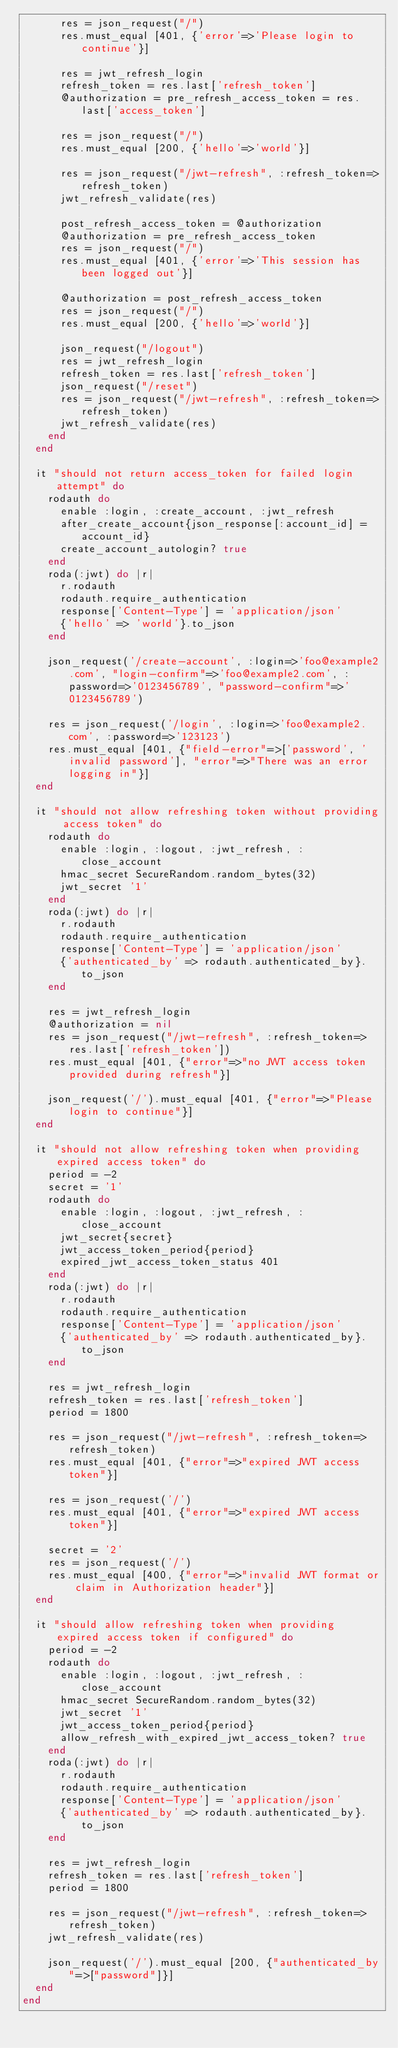Convert code to text. <code><loc_0><loc_0><loc_500><loc_500><_Ruby_>      res = json_request("/")
      res.must_equal [401, {'error'=>'Please login to continue'}]

      res = jwt_refresh_login
      refresh_token = res.last['refresh_token']
      @authorization = pre_refresh_access_token = res.last['access_token']

      res = json_request("/")
      res.must_equal [200, {'hello'=>'world'}]

      res = json_request("/jwt-refresh", :refresh_token=>refresh_token)
      jwt_refresh_validate(res)

      post_refresh_access_token = @authorization
      @authorization = pre_refresh_access_token
      res = json_request("/")
      res.must_equal [401, {'error'=>'This session has been logged out'}]

      @authorization = post_refresh_access_token
      res = json_request("/")
      res.must_equal [200, {'hello'=>'world'}]

      json_request("/logout")
      res = jwt_refresh_login
      refresh_token = res.last['refresh_token']
      json_request("/reset")
      res = json_request("/jwt-refresh", :refresh_token=>refresh_token)
      jwt_refresh_validate(res)
    end
  end

  it "should not return access_token for failed login attempt" do
    rodauth do
      enable :login, :create_account, :jwt_refresh
      after_create_account{json_response[:account_id] = account_id}
      create_account_autologin? true
    end
    roda(:jwt) do |r|
      r.rodauth
      rodauth.require_authentication
      response['Content-Type'] = 'application/json'
      {'hello' => 'world'}.to_json
    end

    json_request('/create-account', :login=>'foo@example2.com', "login-confirm"=>'foo@example2.com', :password=>'0123456789', "password-confirm"=>'0123456789')

    res = json_request('/login', :login=>'foo@example2.com', :password=>'123123')
    res.must_equal [401, {"field-error"=>['password', 'invalid password'], "error"=>"There was an error logging in"}]
  end

  it "should not allow refreshing token without providing access token" do
    rodauth do
      enable :login, :logout, :jwt_refresh, :close_account
      hmac_secret SecureRandom.random_bytes(32)
      jwt_secret '1'
    end
    roda(:jwt) do |r|
      r.rodauth
      rodauth.require_authentication
      response['Content-Type'] = 'application/json'
      {'authenticated_by' => rodauth.authenticated_by}.to_json
    end

    res = jwt_refresh_login
    @authorization = nil
    res = json_request("/jwt-refresh", :refresh_token=>res.last['refresh_token'])
    res.must_equal [401, {"error"=>"no JWT access token provided during refresh"}]

    json_request('/').must_equal [401, {"error"=>"Please login to continue"}]
  end

  it "should not allow refreshing token when providing expired access token" do
    period = -2
    secret = '1'
    rodauth do
      enable :login, :logout, :jwt_refresh, :close_account
      jwt_secret{secret}
      jwt_access_token_period{period}
      expired_jwt_access_token_status 401
    end
    roda(:jwt) do |r|
      r.rodauth
      rodauth.require_authentication
      response['Content-Type'] = 'application/json'
      {'authenticated_by' => rodauth.authenticated_by}.to_json
    end

    res = jwt_refresh_login
    refresh_token = res.last['refresh_token']
    period = 1800

    res = json_request("/jwt-refresh", :refresh_token=>refresh_token)
    res.must_equal [401, {"error"=>"expired JWT access token"}]

    res = json_request('/')
    res.must_equal [401, {"error"=>"expired JWT access token"}]

    secret = '2'
    res = json_request('/')
    res.must_equal [400, {"error"=>"invalid JWT format or claim in Authorization header"}]
  end

  it "should allow refreshing token when providing expired access token if configured" do
    period = -2
    rodauth do
      enable :login, :logout, :jwt_refresh, :close_account
      hmac_secret SecureRandom.random_bytes(32)
      jwt_secret '1'
      jwt_access_token_period{period}
      allow_refresh_with_expired_jwt_access_token? true
    end
    roda(:jwt) do |r|
      r.rodauth
      rodauth.require_authentication
      response['Content-Type'] = 'application/json'
      {'authenticated_by' => rodauth.authenticated_by}.to_json
    end

    res = jwt_refresh_login
    refresh_token = res.last['refresh_token']
    period = 1800

    res = json_request("/jwt-refresh", :refresh_token=>refresh_token)
    jwt_refresh_validate(res)

    json_request('/').must_equal [200, {"authenticated_by"=>["password"]}]
  end
end
</code> 